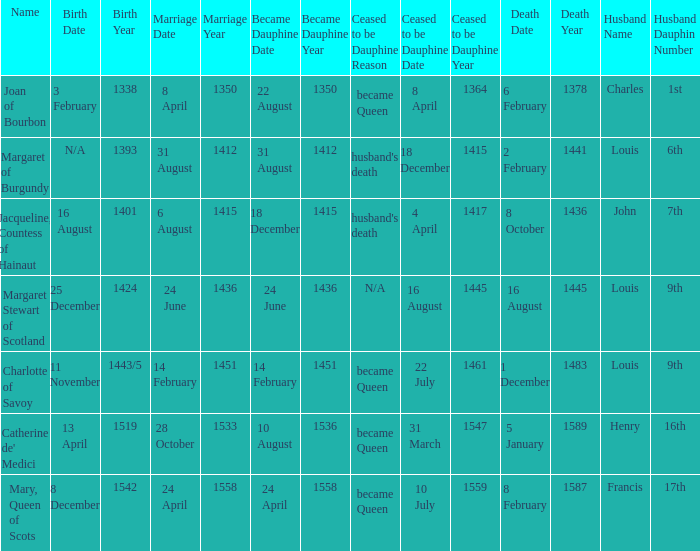When was became dauphine when birth is 1393? 31 August 1412. 